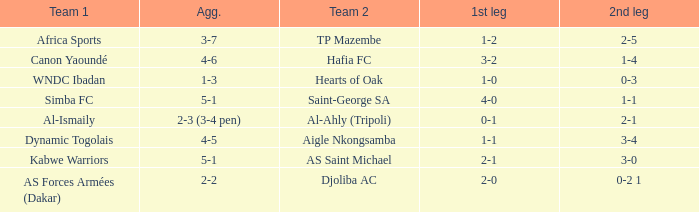What team played against Al-Ismaily (team 1)? Al-Ahly (Tripoli). 